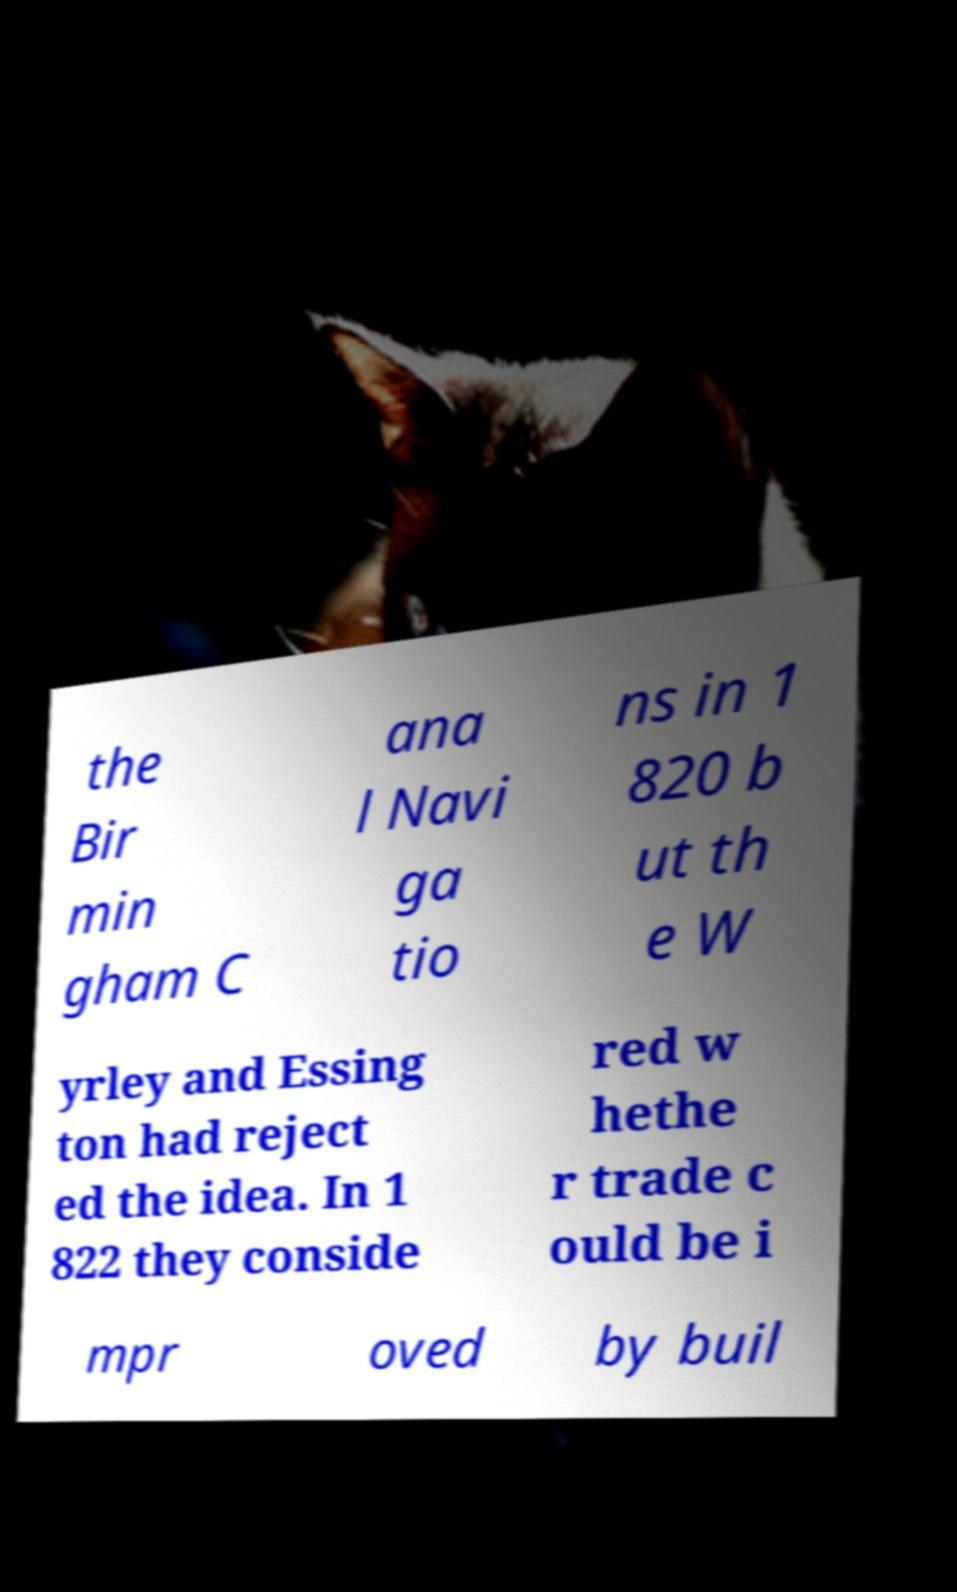Can you accurately transcribe the text from the provided image for me? the Bir min gham C ana l Navi ga tio ns in 1 820 b ut th e W yrley and Essing ton had reject ed the idea. In 1 822 they conside red w hethe r trade c ould be i mpr oved by buil 